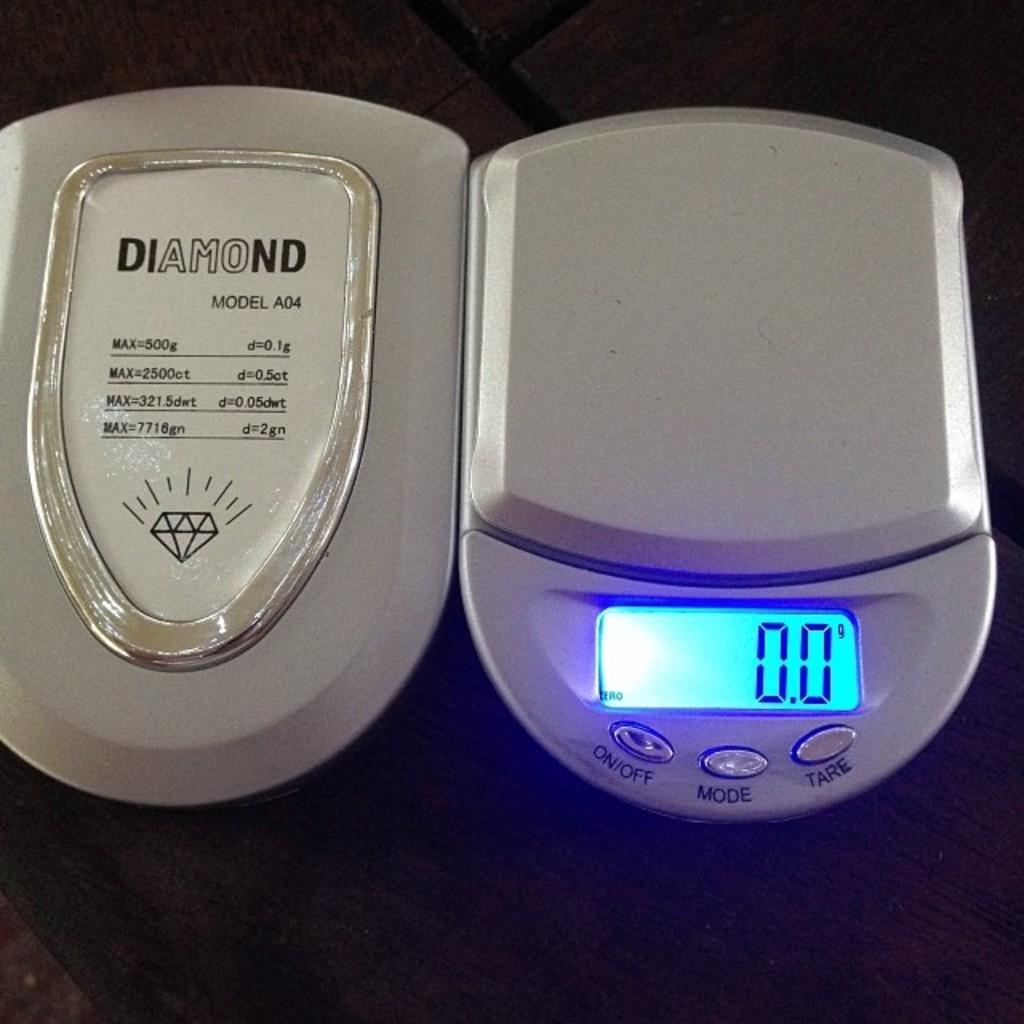<image>
Share a concise interpretation of the image provided. White scale with the option to change the mode set at 0.0 